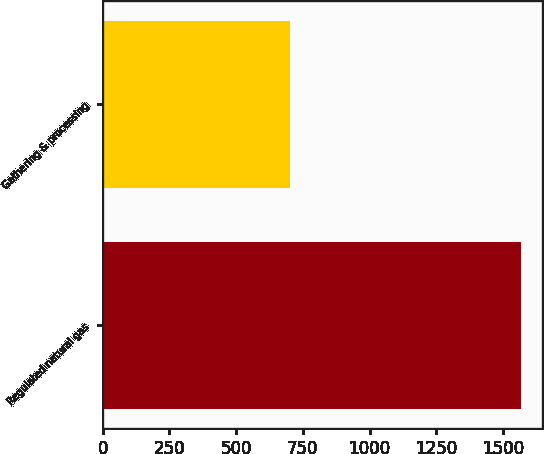<chart> <loc_0><loc_0><loc_500><loc_500><bar_chart><fcel>Regulated natural gas<fcel>Gathering & processing<nl><fcel>1569<fcel>703<nl></chart> 